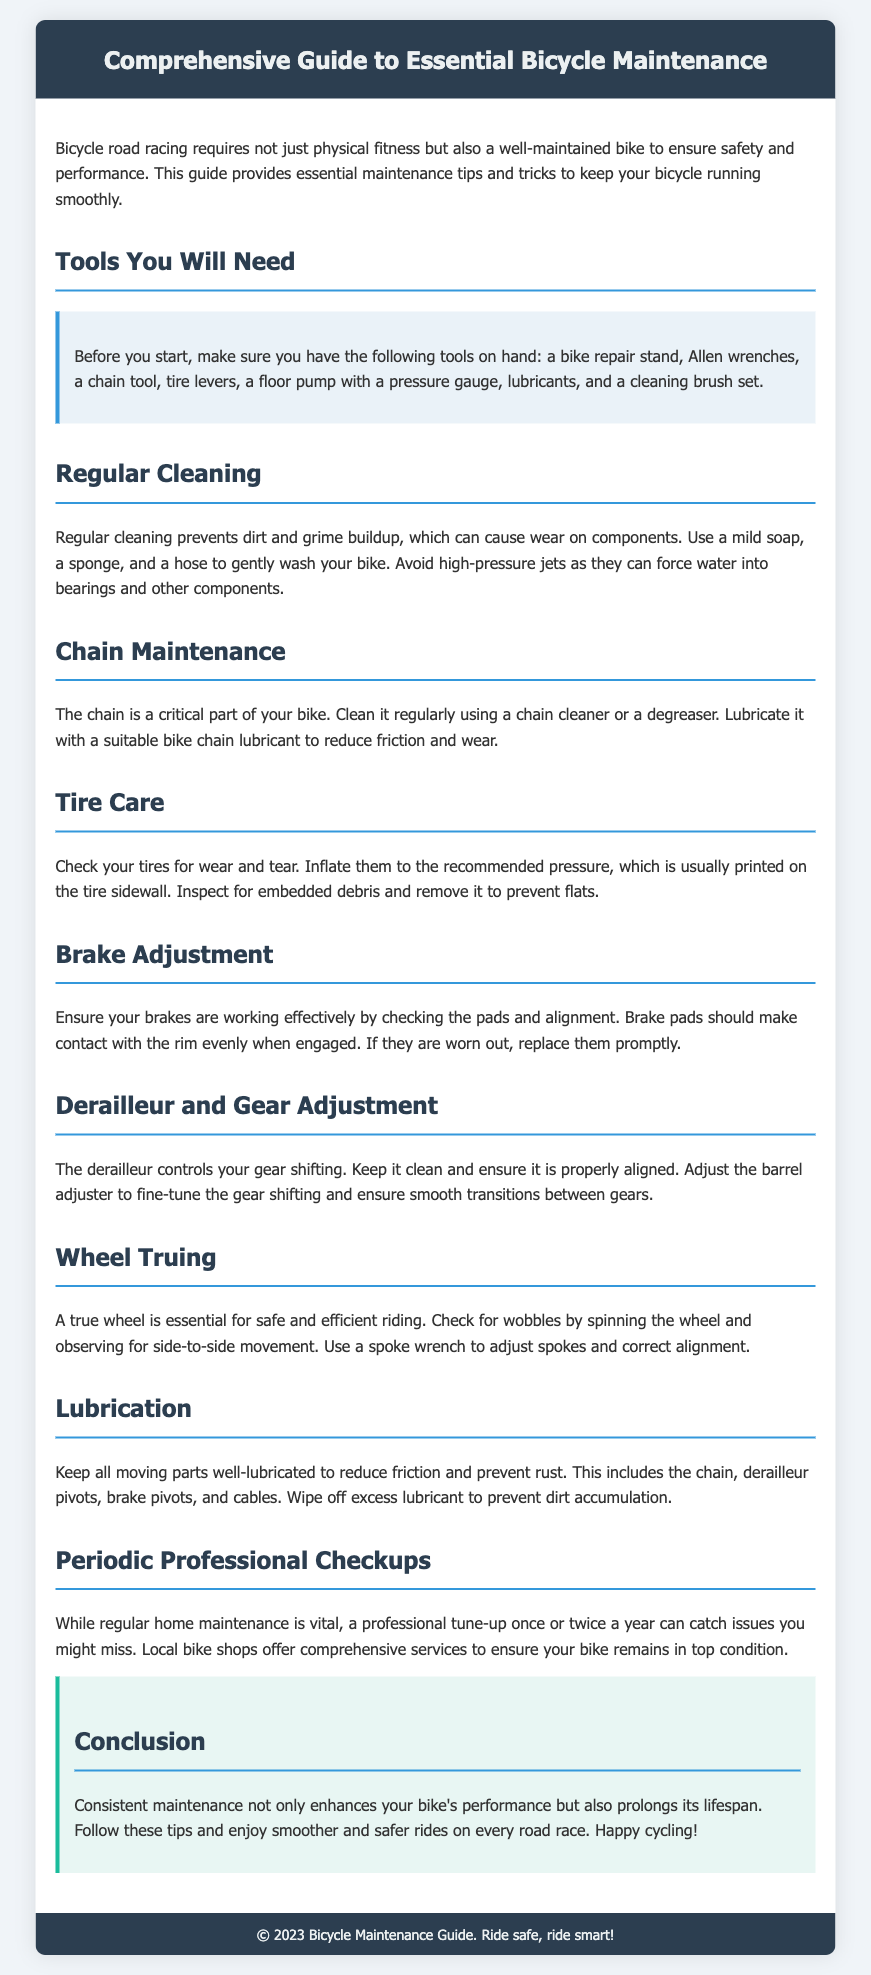What tools are listed in the guide? The tools listed are essential for bicycle maintenance, including items like a bike repair stand and Allen wrenches.
Answer: bike repair stand, Allen wrenches, chain tool, tire levers, floor pump, lubricants, cleaning brush set How often should you check your brakes? The document suggests checking the brakes regularly to ensure effectiveness.
Answer: regularly What is the purpose of lubricating the bike chain? Lubricating the bike chain is necessary to reduce friction and wear on this critical part.
Answer: reduce friction and wear How many professional checkups are recommended annually? The document recommends one or two professional checkups each year to catch issues.
Answer: once or twice What should you do if your wheel is wobbly? The document states to check for side-to-side movement and adjust spokes using a spoke wrench.
Answer: adjust spokes What can cause wear on bike components? Dirt and grime buildup on the bike can lead to wear on various components.
Answer: dirt and grime buildup What is the main focus of this document? The main focus is on providing essential tips and tricks for maintaining bicycles for road racing.
Answer: bicycle maintenance What should be used to clean the bike? The recommended method for cleaning involves using mild soap, a sponge, and a hose.
Answer: mild soap, sponge, hose 